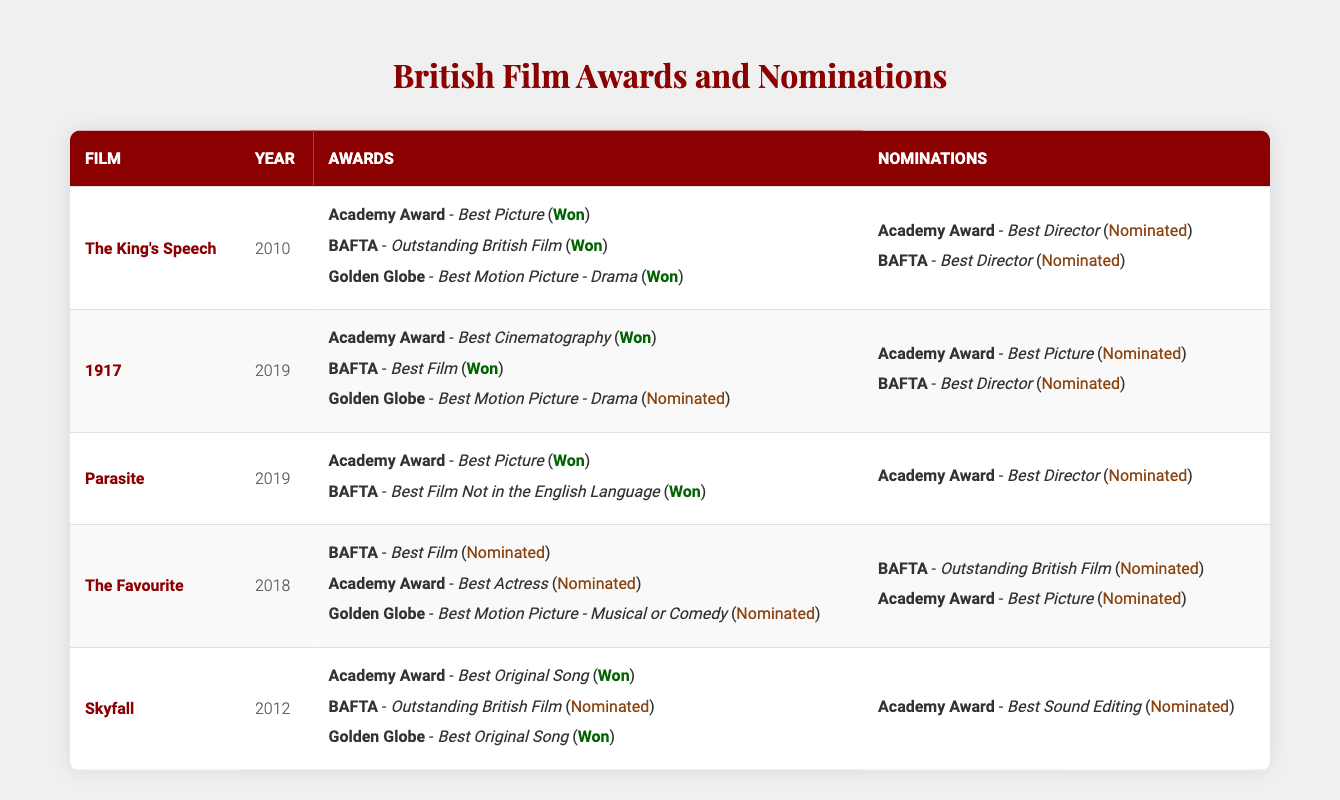What film won the Academy Award for Best Picture in 2010? From the table, "The King's Speech" is listed as the film that won the Academy Award in the Best Picture category in the year 2010.
Answer: The King's Speech How many awards did "1917" win? "1917" won 2 awards listed in the table: Academy Award for Best Cinematography and BAFTA for Best Film.
Answer: 2 Did "Parasite" receive any nominations for the Academy Award? The table indicates that "Parasite" received a nomination for the Academy Award in the Best Director category.
Answer: Yes Which film received the most nominations? By reviewing the table, "The Favourite" has the highest number of nominations listed, with a total of 4 in the nominations section.
Answer: The Favourite How many total awards and nominations did "Skyfall" receive? "Skyfall" received 3 awards (1 won at Academy Awards, 1 won at Golden Globes, and 1 nomination at BAFTA) and 1 nomination for the Academy Award for Best Sound Editing, totaling 4.
Answer: 4 Which films won an award at the Golden Globes? "The King's Speech" and "Skyfall" are the films that won awards at the Golden Globes, as indicated in the table.
Answer: 2 What is the total number of nominations across all listed films? To find this, we add the nominations: "The King's Speech" (2) + "1917" (2) + "Parasite" (1) + "The Favourite" (2) + "Skyfall" (1), giving a total of 8 nominations.
Answer: 8 Was "The Favourite" nominated for any Academy Awards? Yes, "The Favourite" was nominated for the Best Actress Academy Award according to the data presented in the table.
Answer: Yes In which year did "The King's Speech" win the BAFTA for Outstanding British Film? According to the table, "The King's Speech" won the BAFTA for Outstanding British Film in the year 2010.
Answer: 2010 Did any films both win and receive nominations at the same award show? Yes, "Skyfall" won at the Golden Globes for Best Original Song but also received a nomination at the BAFTAs for Outstanding British Film.
Answer: Yes 